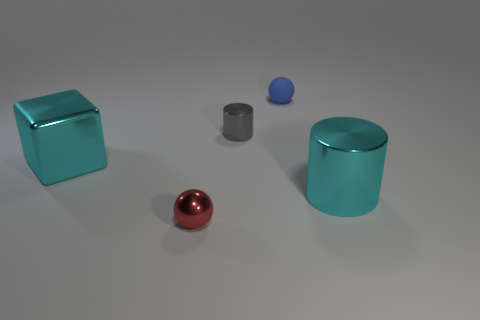Add 2 rubber objects. How many objects exist? 7 Subtract all cubes. How many objects are left? 4 Add 3 tiny brown matte balls. How many tiny brown matte balls exist? 3 Subtract 1 cyan cylinders. How many objects are left? 4 Subtract all small purple cubes. Subtract all small blue rubber things. How many objects are left? 4 Add 5 red things. How many red things are left? 6 